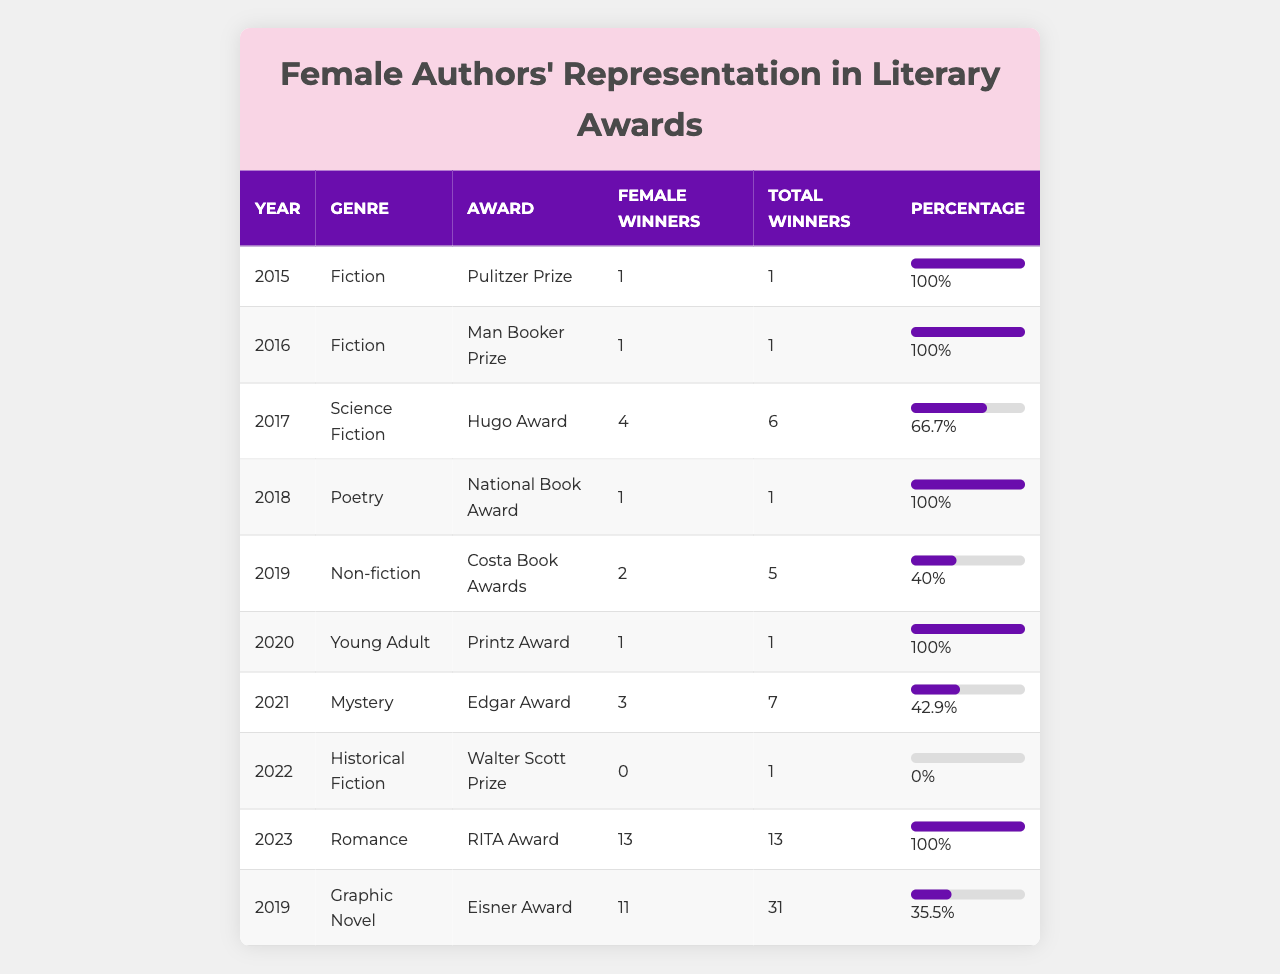What percentage of female winners were there for the Pulitzer Prize in 2015? There was 1 female winner and 1 total winner for the Pulitzer Prize in 2015. The percentage is calculated as (1/1) * 100 = 100%.
Answer: 100% Which genre had the highest percentage of female winners in this table? The RITA Award for Romance in 2023 had 100% of female winners, sharing the title with the Pulitzer Prize in 2015, the Man Booker Prize in 2016, the National Book Award in 2018, and the Printz Award in 2020.
Answer: Romance, Fiction, National Book Award, Printz Award How many female winners were there in the 2021 Edgar Award? For the 2021 Edgar Award, there were 3 female winners out of 7 total winners.
Answer: 3 What is the difference in female winner percentages between the 2019 Costa Book Awards and the 2019 Eisner Award? The Costa Book Awards had 40% female winners while the Eisner Award had 35.5%. The difference is 40% - 35.5% = 4.5%.
Answer: 4.5% Did any genres have zero female winners in this table? Yes, the genre of Historical Fiction at the Walter Scott Prize in 2022 had 0 female winners.
Answer: Yes What was the average percentage of female winners across all awards listed in the table? The percentages are: 100, 100, 66.7, 100, 40, 100, 42.9, 0, 100, and 35.5. The total is 585.1, and there are 10 awards. So the average is 585.1/10 = 58.51%.
Answer: 58.51% Which year had the highest number of female winners, and how many were there? The RITA Award in 2023 had the highest number of female winners with 13 winners out of the total.
Answer: 2023, 13 What is the trend in female representation for the Hugo Award from 2017 to 2022? In 2017, the percentage was 66.7%. Then, using the Walter Scott Prize in 2022 as a comparison, there were no female winners, leading to a decline.
Answer: Decline Were there more female winners in 2023 compared to 2021? Yes, in 2023 there were 13 female winners in the RITA Award, while in 2021 there were only 3 female winners in the Edgar Award.
Answer: Yes How many total winners were there in the 2019 Graphic Novel category? The Eisner Award for the Graphic Novel category in 2019 had a total of 31 winners.
Answer: 31 Which award had the lowest percentage of female winners and what was that percentage? The Walter Scott Prize for Historical Fiction in 2022 had the lowest percentage with 0%.
Answer: 0% 